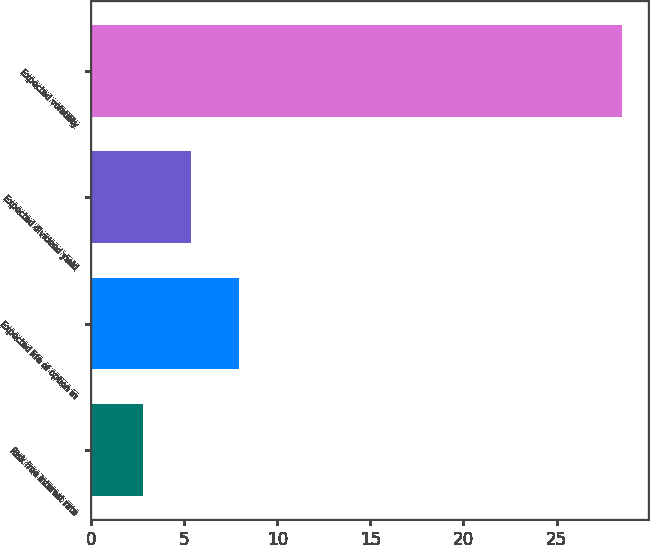<chart> <loc_0><loc_0><loc_500><loc_500><bar_chart><fcel>Risk free interest rate<fcel>Expected life of option in<fcel>Expected dividend yield<fcel>Expected volatility<nl><fcel>2.8<fcel>7.94<fcel>5.37<fcel>28.5<nl></chart> 